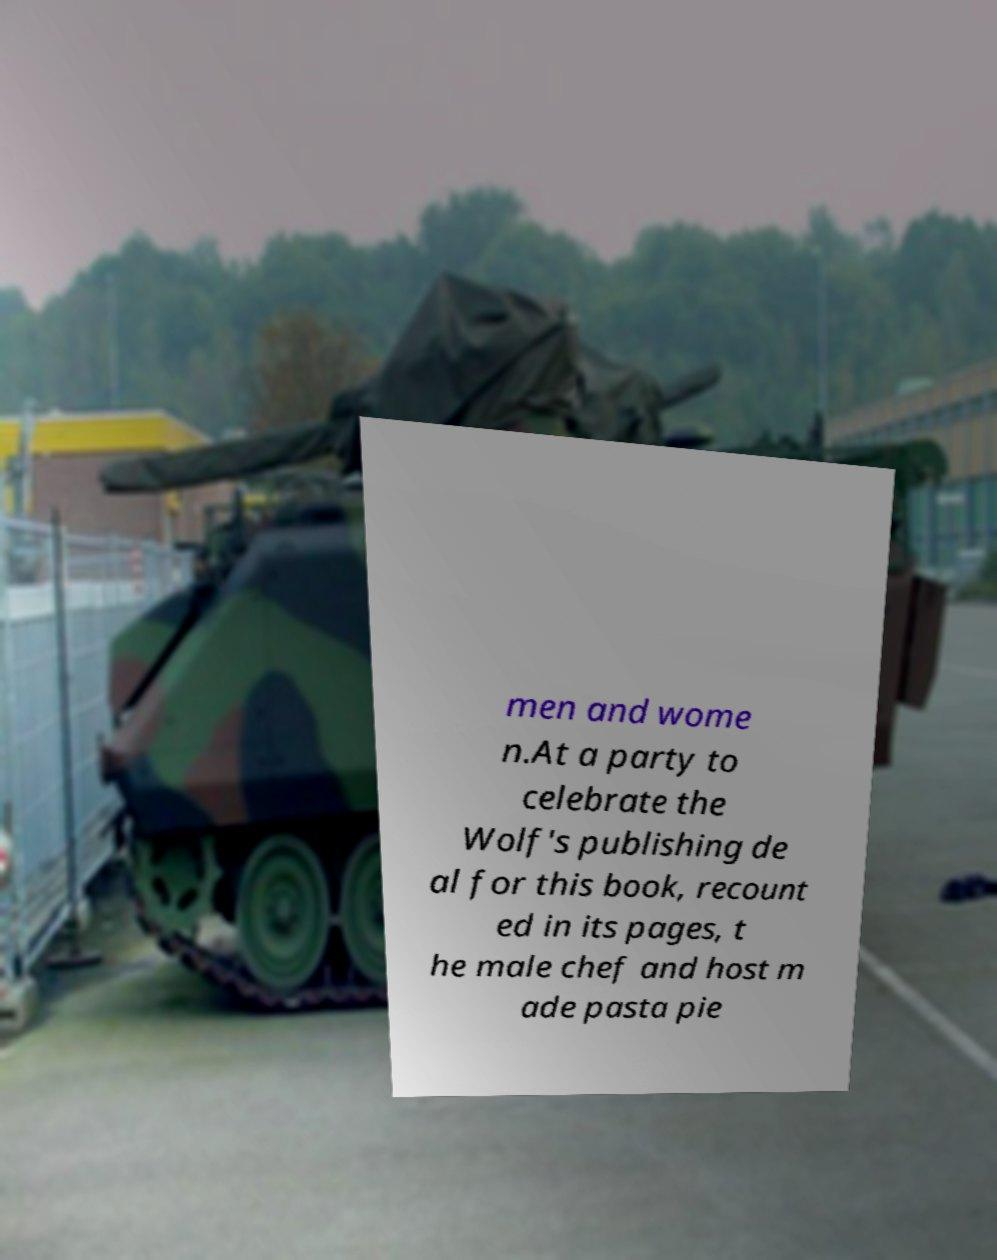Can you accurately transcribe the text from the provided image for me? men and wome n.At a party to celebrate the Wolf's publishing de al for this book, recount ed in its pages, t he male chef and host m ade pasta pie 